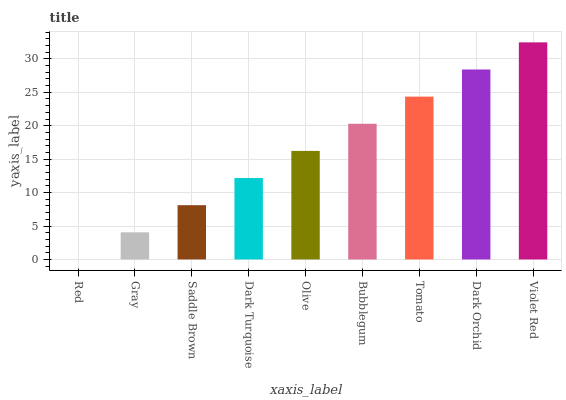Is Red the minimum?
Answer yes or no. Yes. Is Violet Red the maximum?
Answer yes or no. Yes. Is Gray the minimum?
Answer yes or no. No. Is Gray the maximum?
Answer yes or no. No. Is Gray greater than Red?
Answer yes or no. Yes. Is Red less than Gray?
Answer yes or no. Yes. Is Red greater than Gray?
Answer yes or no. No. Is Gray less than Red?
Answer yes or no. No. Is Olive the high median?
Answer yes or no. Yes. Is Olive the low median?
Answer yes or no. Yes. Is Bubblegum the high median?
Answer yes or no. No. Is Violet Red the low median?
Answer yes or no. No. 